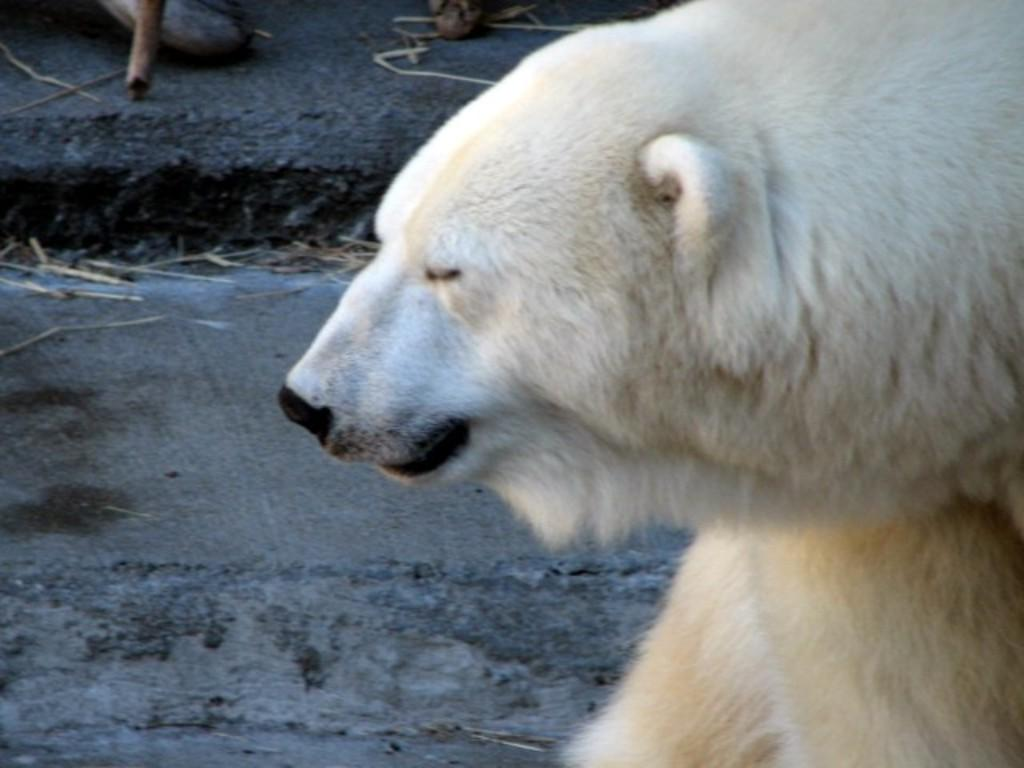What animal is present in the image? There is a bear in the image. Where is the bear located? The bear is on a path. What colors can be seen on the bear? The bear's color is creamy with some parts being white. What type of nail is the bear using to climb the tree in the image? There is no tree or nail present in the image; the bear is on a path. 